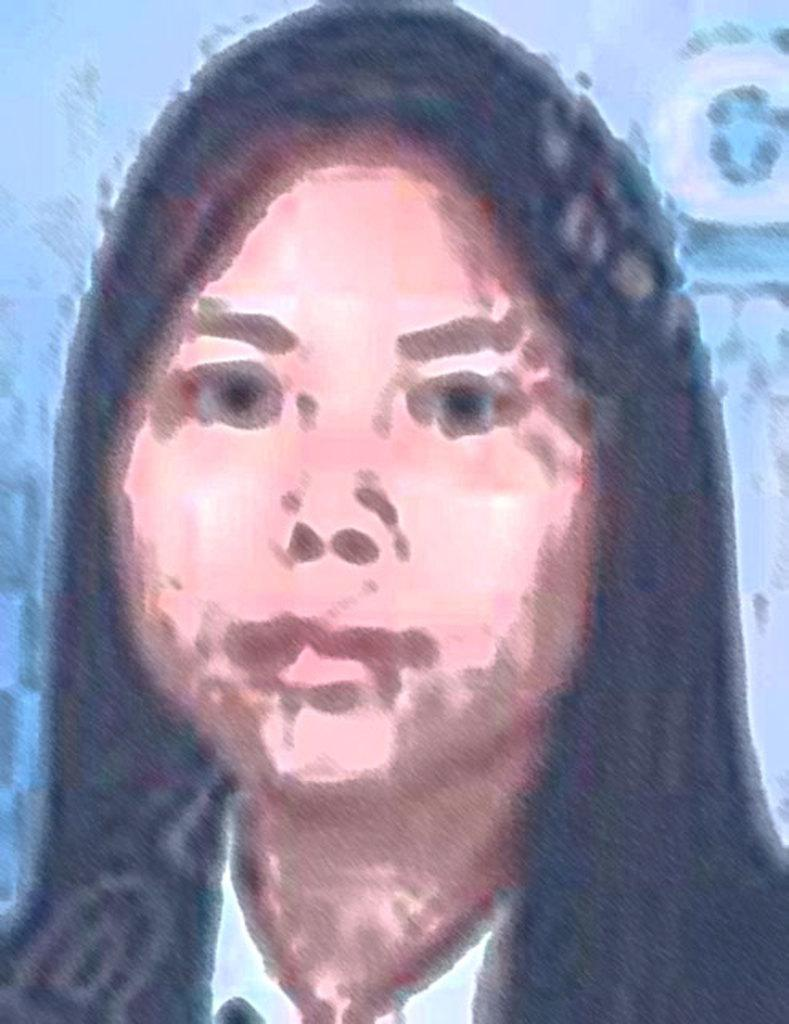What is the main subject of the image? The main subject of the image is a painted woman's face. Can you describe the woman's face in the image? The image features a painted woman's face, but no specific details about her features are provided. How many deer are visible in the image? There are no deer present in the image; it features a painted woman's face. What word is written on the woman's forehead in the image? There is no word written on the woman's forehead in the image; it only features her face. 